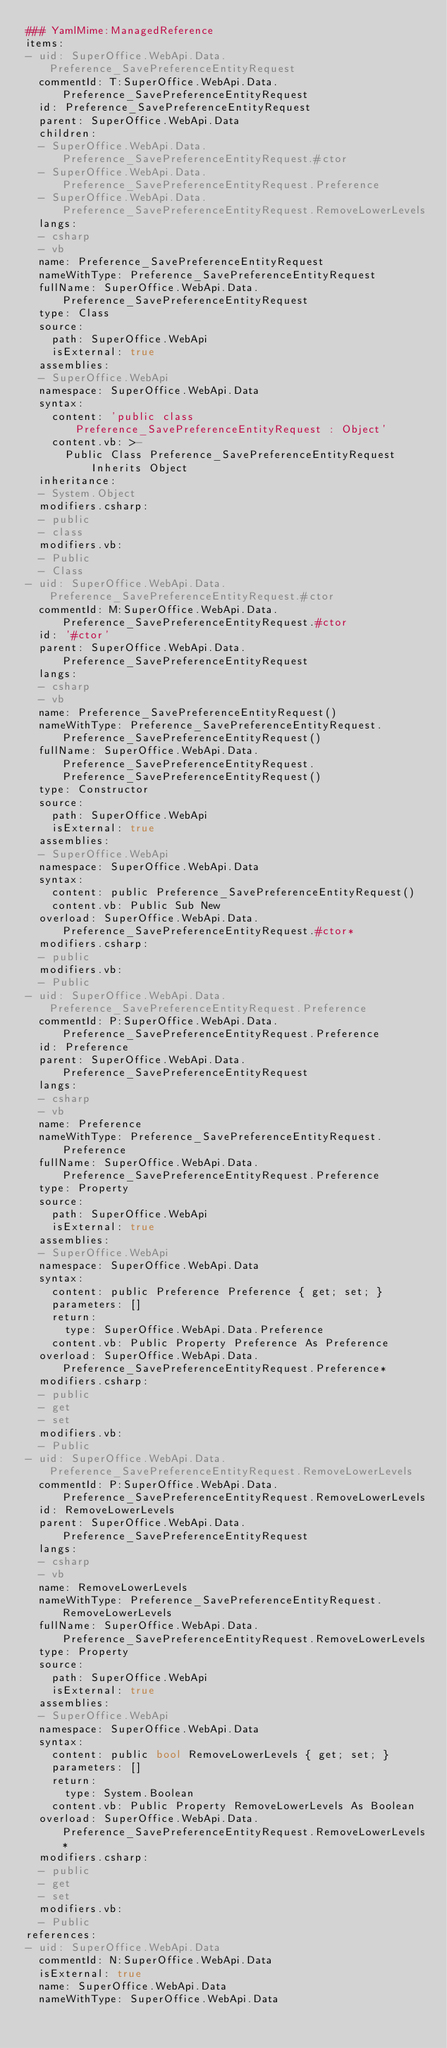Convert code to text. <code><loc_0><loc_0><loc_500><loc_500><_YAML_>### YamlMime:ManagedReference
items:
- uid: SuperOffice.WebApi.Data.Preference_SavePreferenceEntityRequest
  commentId: T:SuperOffice.WebApi.Data.Preference_SavePreferenceEntityRequest
  id: Preference_SavePreferenceEntityRequest
  parent: SuperOffice.WebApi.Data
  children:
  - SuperOffice.WebApi.Data.Preference_SavePreferenceEntityRequest.#ctor
  - SuperOffice.WebApi.Data.Preference_SavePreferenceEntityRequest.Preference
  - SuperOffice.WebApi.Data.Preference_SavePreferenceEntityRequest.RemoveLowerLevels
  langs:
  - csharp
  - vb
  name: Preference_SavePreferenceEntityRequest
  nameWithType: Preference_SavePreferenceEntityRequest
  fullName: SuperOffice.WebApi.Data.Preference_SavePreferenceEntityRequest
  type: Class
  source:
    path: SuperOffice.WebApi
    isExternal: true
  assemblies:
  - SuperOffice.WebApi
  namespace: SuperOffice.WebApi.Data
  syntax:
    content: 'public class Preference_SavePreferenceEntityRequest : Object'
    content.vb: >-
      Public Class Preference_SavePreferenceEntityRequest
          Inherits Object
  inheritance:
  - System.Object
  modifiers.csharp:
  - public
  - class
  modifiers.vb:
  - Public
  - Class
- uid: SuperOffice.WebApi.Data.Preference_SavePreferenceEntityRequest.#ctor
  commentId: M:SuperOffice.WebApi.Data.Preference_SavePreferenceEntityRequest.#ctor
  id: '#ctor'
  parent: SuperOffice.WebApi.Data.Preference_SavePreferenceEntityRequest
  langs:
  - csharp
  - vb
  name: Preference_SavePreferenceEntityRequest()
  nameWithType: Preference_SavePreferenceEntityRequest.Preference_SavePreferenceEntityRequest()
  fullName: SuperOffice.WebApi.Data.Preference_SavePreferenceEntityRequest.Preference_SavePreferenceEntityRequest()
  type: Constructor
  source:
    path: SuperOffice.WebApi
    isExternal: true
  assemblies:
  - SuperOffice.WebApi
  namespace: SuperOffice.WebApi.Data
  syntax:
    content: public Preference_SavePreferenceEntityRequest()
    content.vb: Public Sub New
  overload: SuperOffice.WebApi.Data.Preference_SavePreferenceEntityRequest.#ctor*
  modifiers.csharp:
  - public
  modifiers.vb:
  - Public
- uid: SuperOffice.WebApi.Data.Preference_SavePreferenceEntityRequest.Preference
  commentId: P:SuperOffice.WebApi.Data.Preference_SavePreferenceEntityRequest.Preference
  id: Preference
  parent: SuperOffice.WebApi.Data.Preference_SavePreferenceEntityRequest
  langs:
  - csharp
  - vb
  name: Preference
  nameWithType: Preference_SavePreferenceEntityRequest.Preference
  fullName: SuperOffice.WebApi.Data.Preference_SavePreferenceEntityRequest.Preference
  type: Property
  source:
    path: SuperOffice.WebApi
    isExternal: true
  assemblies:
  - SuperOffice.WebApi
  namespace: SuperOffice.WebApi.Data
  syntax:
    content: public Preference Preference { get; set; }
    parameters: []
    return:
      type: SuperOffice.WebApi.Data.Preference
    content.vb: Public Property Preference As Preference
  overload: SuperOffice.WebApi.Data.Preference_SavePreferenceEntityRequest.Preference*
  modifiers.csharp:
  - public
  - get
  - set
  modifiers.vb:
  - Public
- uid: SuperOffice.WebApi.Data.Preference_SavePreferenceEntityRequest.RemoveLowerLevels
  commentId: P:SuperOffice.WebApi.Data.Preference_SavePreferenceEntityRequest.RemoveLowerLevels
  id: RemoveLowerLevels
  parent: SuperOffice.WebApi.Data.Preference_SavePreferenceEntityRequest
  langs:
  - csharp
  - vb
  name: RemoveLowerLevels
  nameWithType: Preference_SavePreferenceEntityRequest.RemoveLowerLevels
  fullName: SuperOffice.WebApi.Data.Preference_SavePreferenceEntityRequest.RemoveLowerLevels
  type: Property
  source:
    path: SuperOffice.WebApi
    isExternal: true
  assemblies:
  - SuperOffice.WebApi
  namespace: SuperOffice.WebApi.Data
  syntax:
    content: public bool RemoveLowerLevels { get; set; }
    parameters: []
    return:
      type: System.Boolean
    content.vb: Public Property RemoveLowerLevels As Boolean
  overload: SuperOffice.WebApi.Data.Preference_SavePreferenceEntityRequest.RemoveLowerLevels*
  modifiers.csharp:
  - public
  - get
  - set
  modifiers.vb:
  - Public
references:
- uid: SuperOffice.WebApi.Data
  commentId: N:SuperOffice.WebApi.Data
  isExternal: true
  name: SuperOffice.WebApi.Data
  nameWithType: SuperOffice.WebApi.Data</code> 